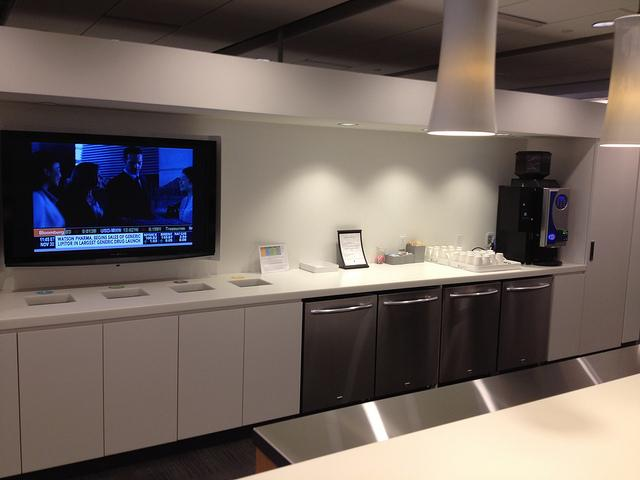What station is on the television?

Choices:
A) cnn
B) fox
C) tbs
D) bloomberg bloomberg 